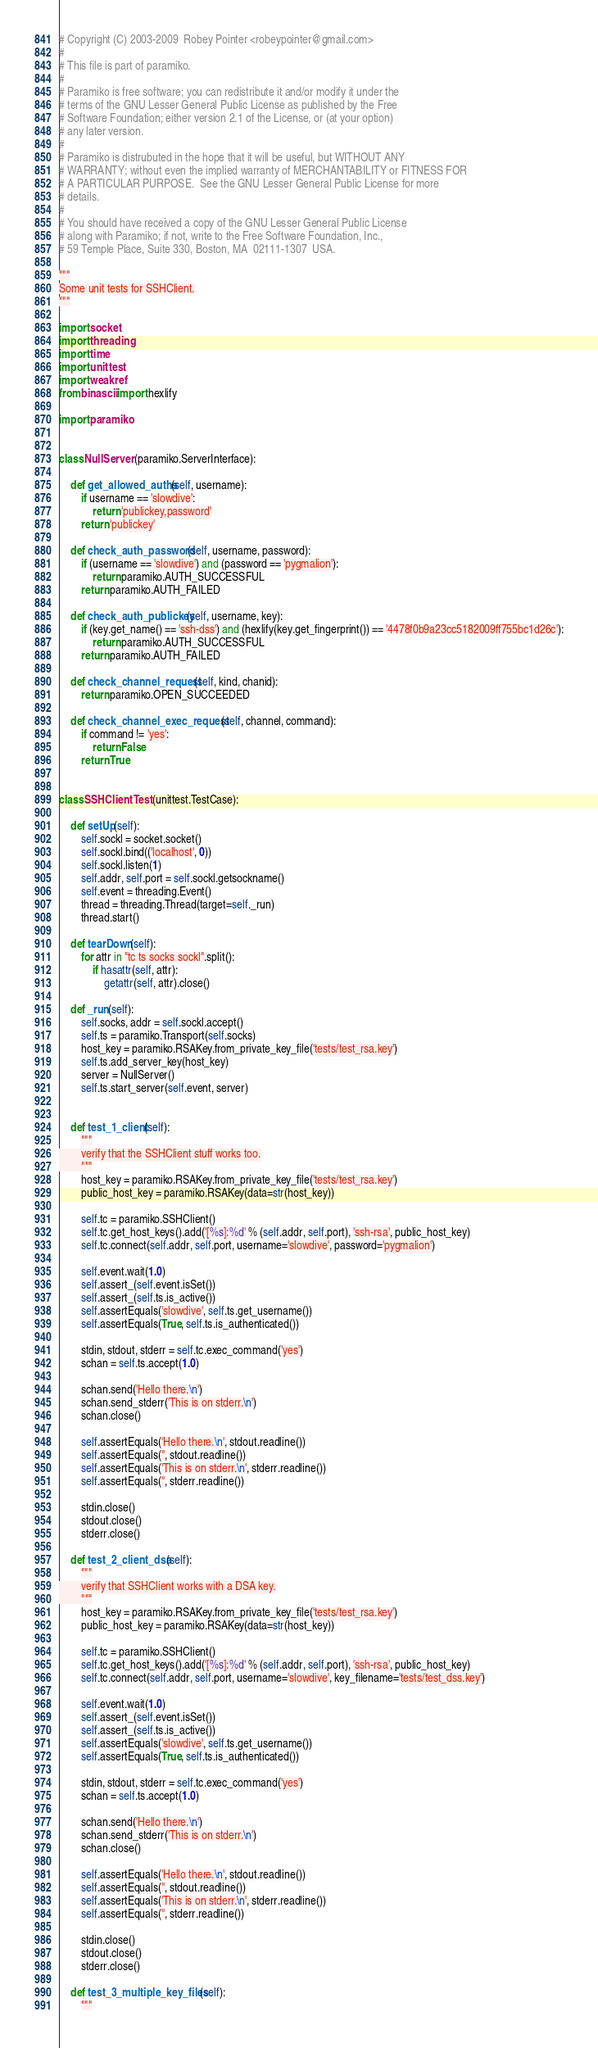Convert code to text. <code><loc_0><loc_0><loc_500><loc_500><_Python_># Copyright (C) 2003-2009  Robey Pointer <robeypointer@gmail.com>
#
# This file is part of paramiko.
#
# Paramiko is free software; you can redistribute it and/or modify it under the
# terms of the GNU Lesser General Public License as published by the Free
# Software Foundation; either version 2.1 of the License, or (at your option)
# any later version.
#
# Paramiko is distrubuted in the hope that it will be useful, but WITHOUT ANY
# WARRANTY; without even the implied warranty of MERCHANTABILITY or FITNESS FOR
# A PARTICULAR PURPOSE.  See the GNU Lesser General Public License for more
# details.
#
# You should have received a copy of the GNU Lesser General Public License
# along with Paramiko; if not, write to the Free Software Foundation, Inc.,
# 59 Temple Place, Suite 330, Boston, MA  02111-1307  USA.

"""
Some unit tests for SSHClient.
"""

import socket
import threading
import time
import unittest
import weakref
from binascii import hexlify

import paramiko


class NullServer (paramiko.ServerInterface):

    def get_allowed_auths(self, username):
        if username == 'slowdive':
            return 'publickey,password'
        return 'publickey'

    def check_auth_password(self, username, password):
        if (username == 'slowdive') and (password == 'pygmalion'):
            return paramiko.AUTH_SUCCESSFUL
        return paramiko.AUTH_FAILED

    def check_auth_publickey(self, username, key):
        if (key.get_name() == 'ssh-dss') and (hexlify(key.get_fingerprint()) == '4478f0b9a23cc5182009ff755bc1d26c'):
            return paramiko.AUTH_SUCCESSFUL
        return paramiko.AUTH_FAILED

    def check_channel_request(self, kind, chanid):
        return paramiko.OPEN_SUCCEEDED

    def check_channel_exec_request(self, channel, command):
        if command != 'yes':
            return False
        return True


class SSHClientTest (unittest.TestCase):

    def setUp(self):
        self.sockl = socket.socket()
        self.sockl.bind(('localhost', 0))
        self.sockl.listen(1)
        self.addr, self.port = self.sockl.getsockname()
        self.event = threading.Event()
        thread = threading.Thread(target=self._run)
        thread.start()

    def tearDown(self):
        for attr in "tc ts socks sockl".split():
            if hasattr(self, attr):
                getattr(self, attr).close()

    def _run(self):
        self.socks, addr = self.sockl.accept()
        self.ts = paramiko.Transport(self.socks)
        host_key = paramiko.RSAKey.from_private_key_file('tests/test_rsa.key')
        self.ts.add_server_key(host_key)
        server = NullServer()
        self.ts.start_server(self.event, server)


    def test_1_client(self):
        """
        verify that the SSHClient stuff works too.
        """
        host_key = paramiko.RSAKey.from_private_key_file('tests/test_rsa.key')
        public_host_key = paramiko.RSAKey(data=str(host_key))

        self.tc = paramiko.SSHClient()
        self.tc.get_host_keys().add('[%s]:%d' % (self.addr, self.port), 'ssh-rsa', public_host_key)
        self.tc.connect(self.addr, self.port, username='slowdive', password='pygmalion')

        self.event.wait(1.0)
        self.assert_(self.event.isSet())
        self.assert_(self.ts.is_active())
        self.assertEquals('slowdive', self.ts.get_username())
        self.assertEquals(True, self.ts.is_authenticated())

        stdin, stdout, stderr = self.tc.exec_command('yes')
        schan = self.ts.accept(1.0)

        schan.send('Hello there.\n')
        schan.send_stderr('This is on stderr.\n')
        schan.close()

        self.assertEquals('Hello there.\n', stdout.readline())
        self.assertEquals('', stdout.readline())
        self.assertEquals('This is on stderr.\n', stderr.readline())
        self.assertEquals('', stderr.readline())

        stdin.close()
        stdout.close()
        stderr.close()

    def test_2_client_dsa(self):
        """
        verify that SSHClient works with a DSA key.
        """
        host_key = paramiko.RSAKey.from_private_key_file('tests/test_rsa.key')
        public_host_key = paramiko.RSAKey(data=str(host_key))

        self.tc = paramiko.SSHClient()
        self.tc.get_host_keys().add('[%s]:%d' % (self.addr, self.port), 'ssh-rsa', public_host_key)
        self.tc.connect(self.addr, self.port, username='slowdive', key_filename='tests/test_dss.key')

        self.event.wait(1.0)
        self.assert_(self.event.isSet())
        self.assert_(self.ts.is_active())
        self.assertEquals('slowdive', self.ts.get_username())
        self.assertEquals(True, self.ts.is_authenticated())

        stdin, stdout, stderr = self.tc.exec_command('yes')
        schan = self.ts.accept(1.0)

        schan.send('Hello there.\n')
        schan.send_stderr('This is on stderr.\n')
        schan.close()

        self.assertEquals('Hello there.\n', stdout.readline())
        self.assertEquals('', stdout.readline())
        self.assertEquals('This is on stderr.\n', stderr.readline())
        self.assertEquals('', stderr.readline())

        stdin.close()
        stdout.close()
        stderr.close()

    def test_3_multiple_key_files(self):
        """</code> 